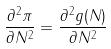<formula> <loc_0><loc_0><loc_500><loc_500>\frac { \partial ^ { 2 } \pi } { \partial N ^ { 2 } } = \frac { \partial ^ { 2 } g ( N ) } { \partial N ^ { 2 } }</formula> 